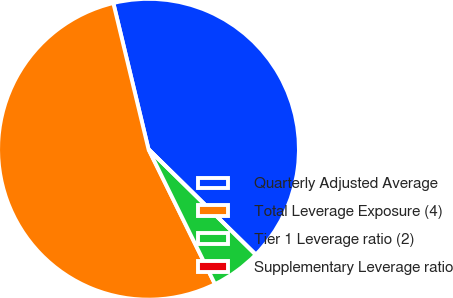Convert chart. <chart><loc_0><loc_0><loc_500><loc_500><pie_chart><fcel>Quarterly Adjusted Average<fcel>Total Leverage Exposure (4)<fcel>Tier 1 Leverage ratio (2)<fcel>Supplementary Leverage ratio<nl><fcel>41.12%<fcel>53.53%<fcel>5.35%<fcel>0.0%<nl></chart> 